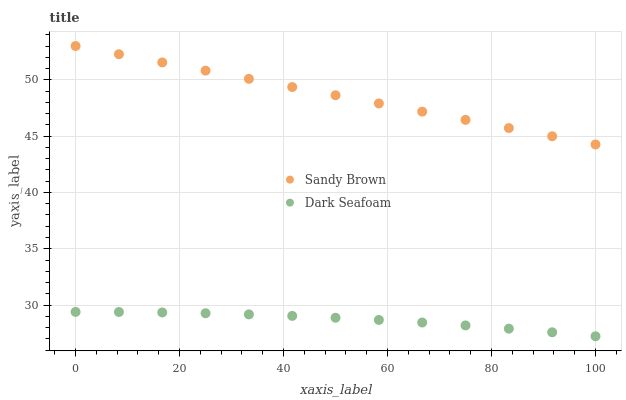Does Dark Seafoam have the minimum area under the curve?
Answer yes or no. Yes. Does Sandy Brown have the maximum area under the curve?
Answer yes or no. Yes. Does Sandy Brown have the minimum area under the curve?
Answer yes or no. No. Is Sandy Brown the smoothest?
Answer yes or no. Yes. Is Dark Seafoam the roughest?
Answer yes or no. Yes. Is Sandy Brown the roughest?
Answer yes or no. No. Does Dark Seafoam have the lowest value?
Answer yes or no. Yes. Does Sandy Brown have the lowest value?
Answer yes or no. No. Does Sandy Brown have the highest value?
Answer yes or no. Yes. Is Dark Seafoam less than Sandy Brown?
Answer yes or no. Yes. Is Sandy Brown greater than Dark Seafoam?
Answer yes or no. Yes. Does Dark Seafoam intersect Sandy Brown?
Answer yes or no. No. 